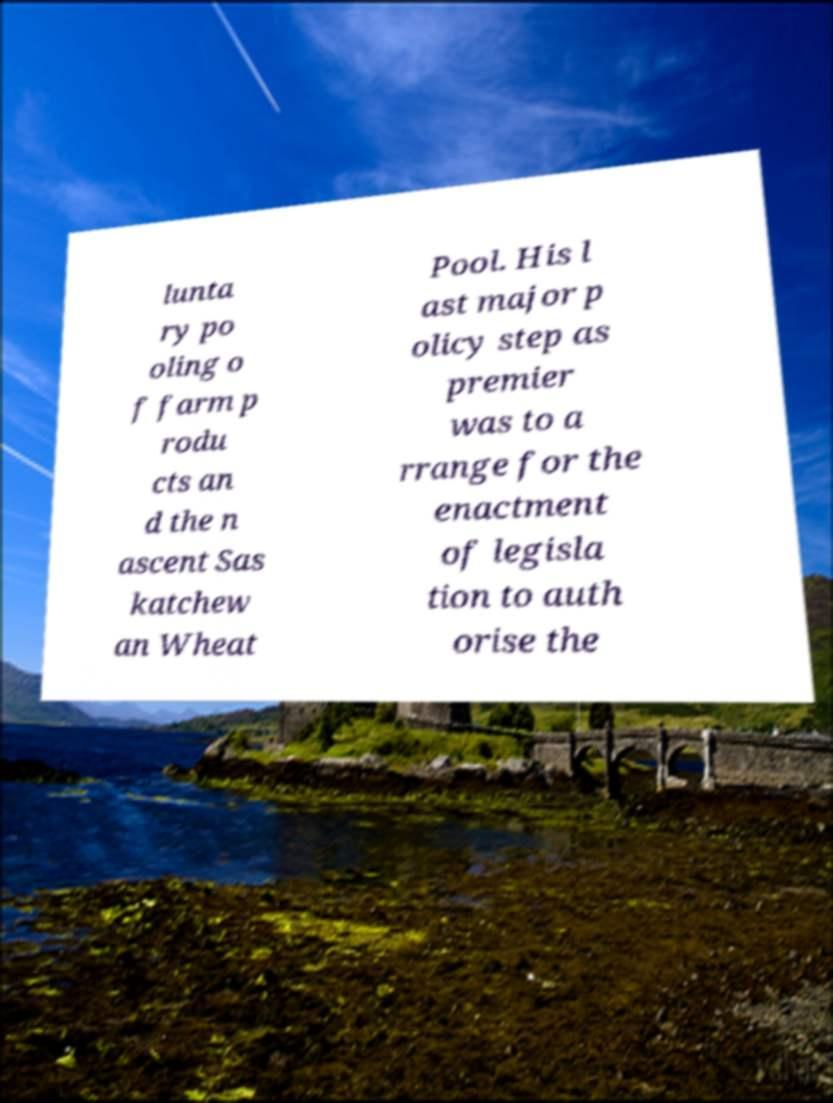I need the written content from this picture converted into text. Can you do that? lunta ry po oling o f farm p rodu cts an d the n ascent Sas katchew an Wheat Pool. His l ast major p olicy step as premier was to a rrange for the enactment of legisla tion to auth orise the 